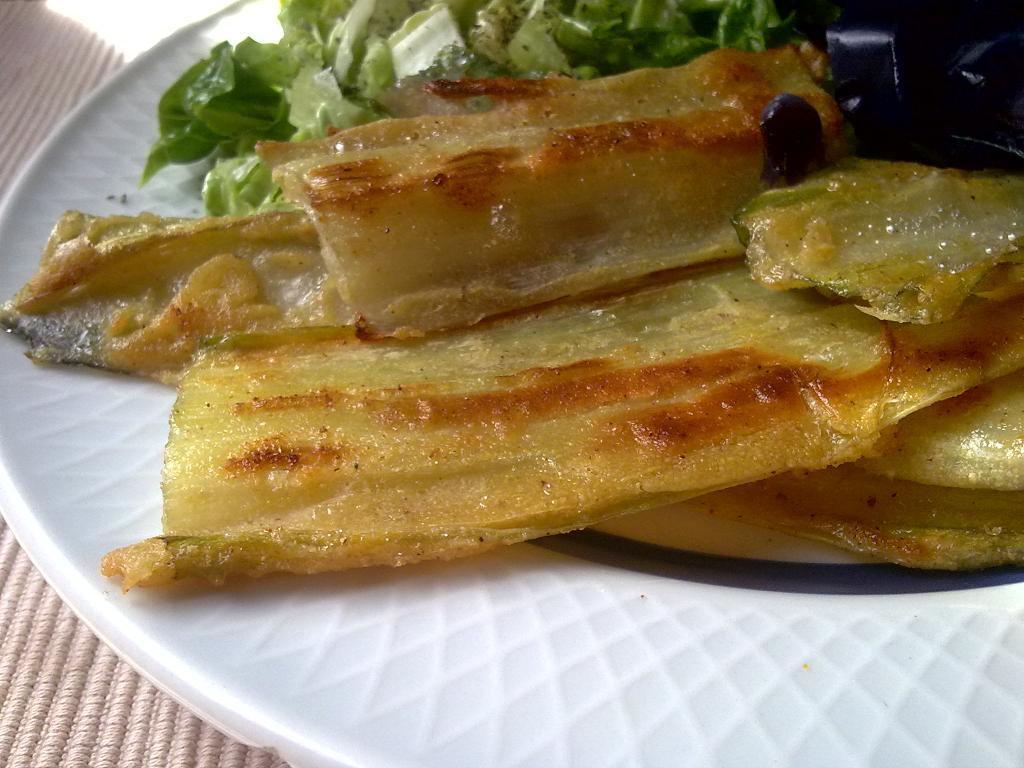How would you summarize this image in a sentence or two? In this picture there is a plate in the center of the image, which contains food items in it. 